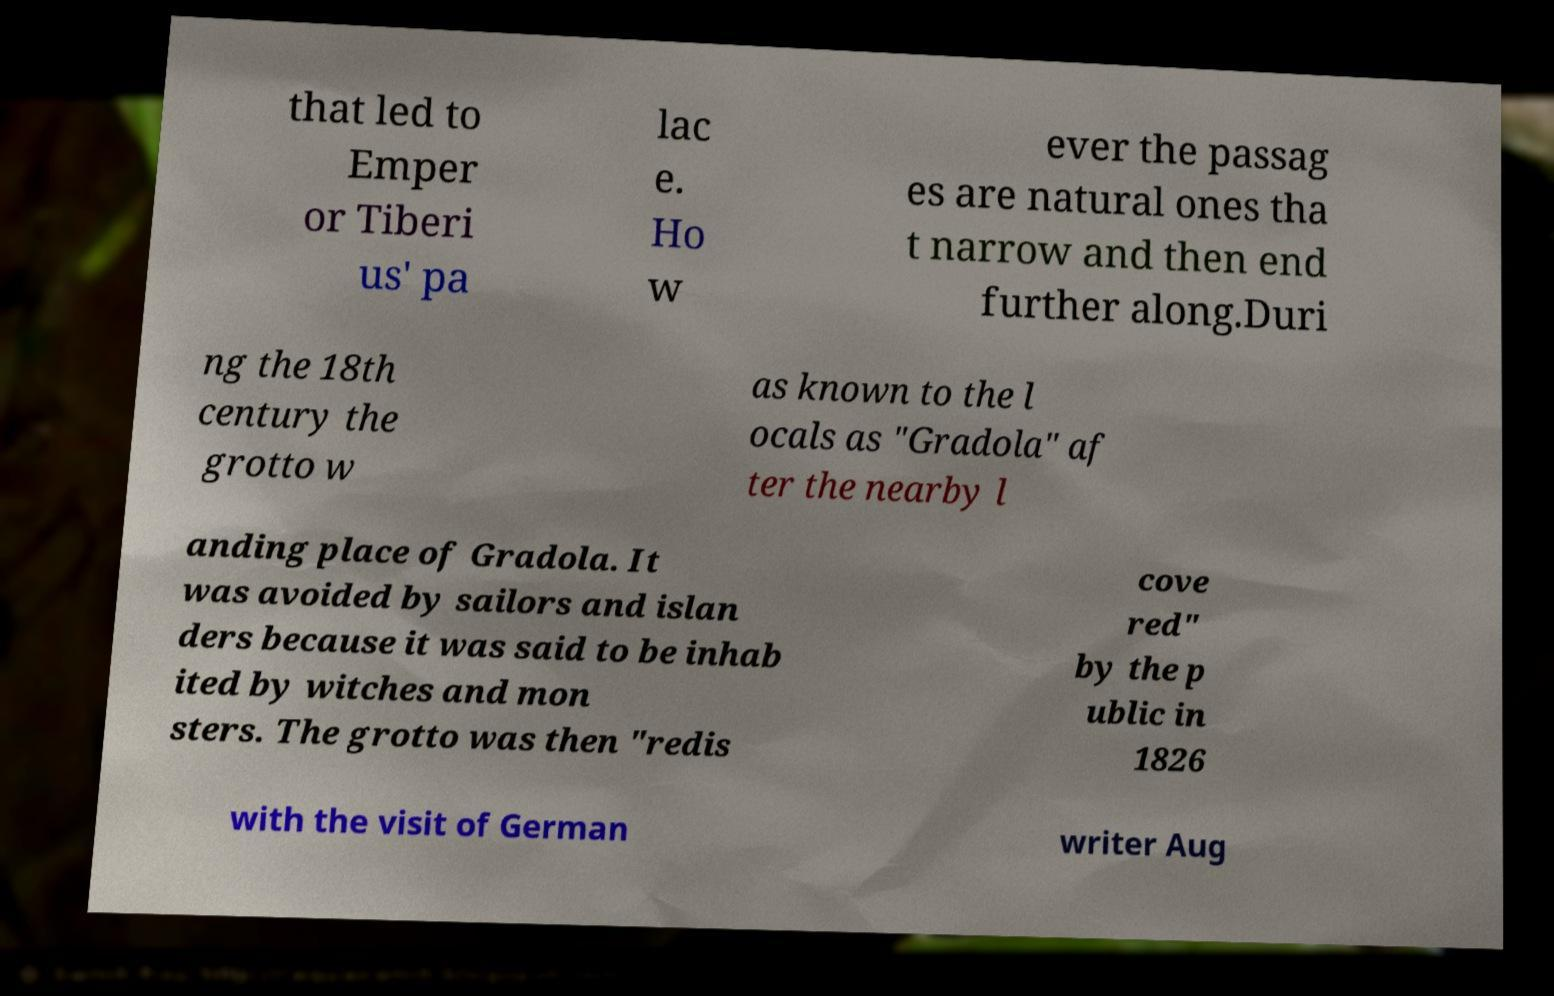Please identify and transcribe the text found in this image. that led to Emper or Tiberi us' pa lac e. Ho w ever the passag es are natural ones tha t narrow and then end further along.Duri ng the 18th century the grotto w as known to the l ocals as "Gradola" af ter the nearby l anding place of Gradola. It was avoided by sailors and islan ders because it was said to be inhab ited by witches and mon sters. The grotto was then "redis cove red" by the p ublic in 1826 with the visit of German writer Aug 